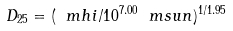Convert formula to latex. <formula><loc_0><loc_0><loc_500><loc_500>D _ { 2 5 } = ( \ m h i / 1 0 ^ { 7 . 0 0 } \ m s u n ) ^ { 1 / 1 . 9 5 }</formula> 